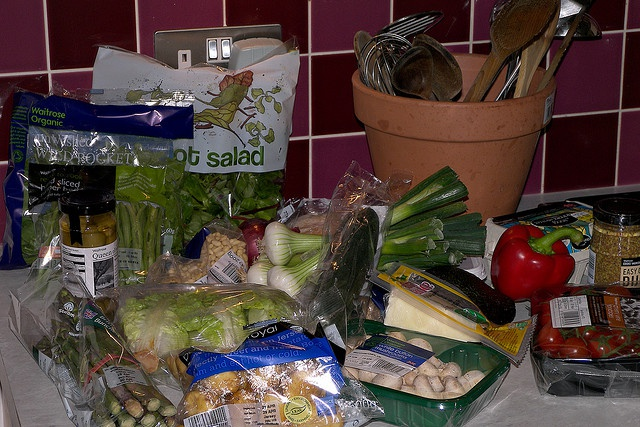Describe the objects in this image and their specific colors. I can see bowl in purple, maroon, brown, and black tones, dining table in purple, gray, and black tones, spoon in purple, black, maroon, and gray tones, bottle in purple, black, darkgray, and gray tones, and bottle in purple, black, olive, maroon, and gray tones in this image. 